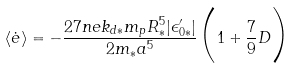<formula> <loc_0><loc_0><loc_500><loc_500>\langle \dot { e } \rangle = - \frac { 2 7 n e k _ { d \ast } m _ { p } R _ { \ast } ^ { 5 } | \epsilon ^ { \prime } _ { 0 \ast } | } { 2 m _ { \ast } a ^ { 5 } } \Big { ( } 1 + \frac { 7 } { 9 } D \Big { ) }</formula> 